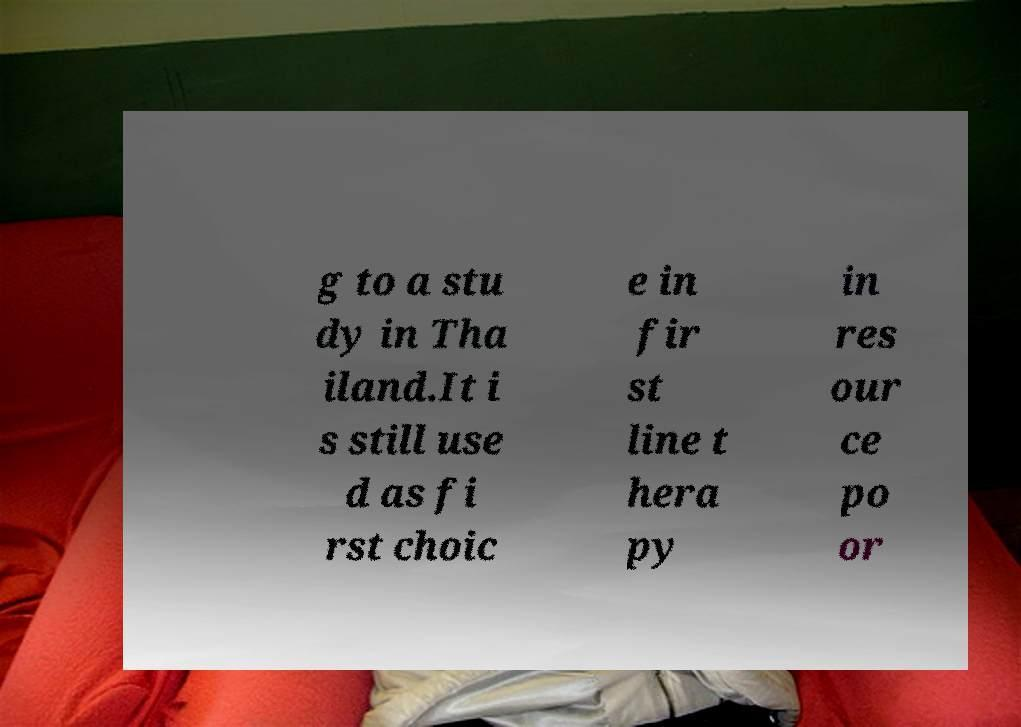Can you accurately transcribe the text from the provided image for me? g to a stu dy in Tha iland.It i s still use d as fi rst choic e in fir st line t hera py in res our ce po or 